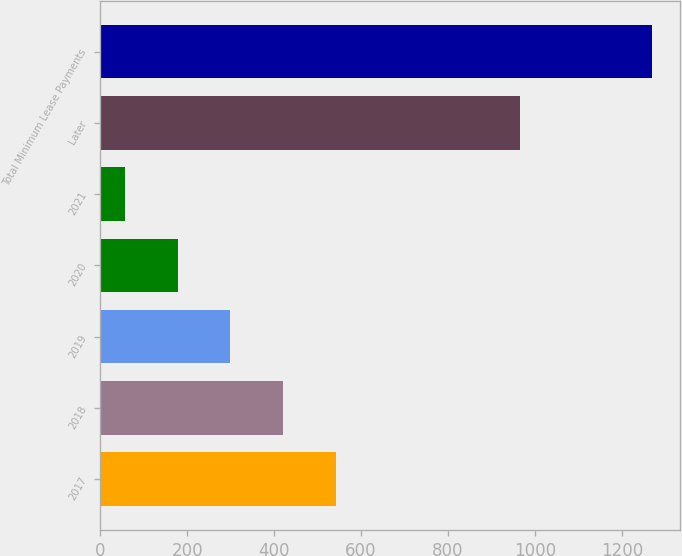Convert chart. <chart><loc_0><loc_0><loc_500><loc_500><bar_chart><fcel>2017<fcel>2018<fcel>2019<fcel>2020<fcel>2021<fcel>Later<fcel>Total Minimum Lease Payments<nl><fcel>542.2<fcel>420.9<fcel>299.6<fcel>178.3<fcel>57<fcel>966<fcel>1270<nl></chart> 